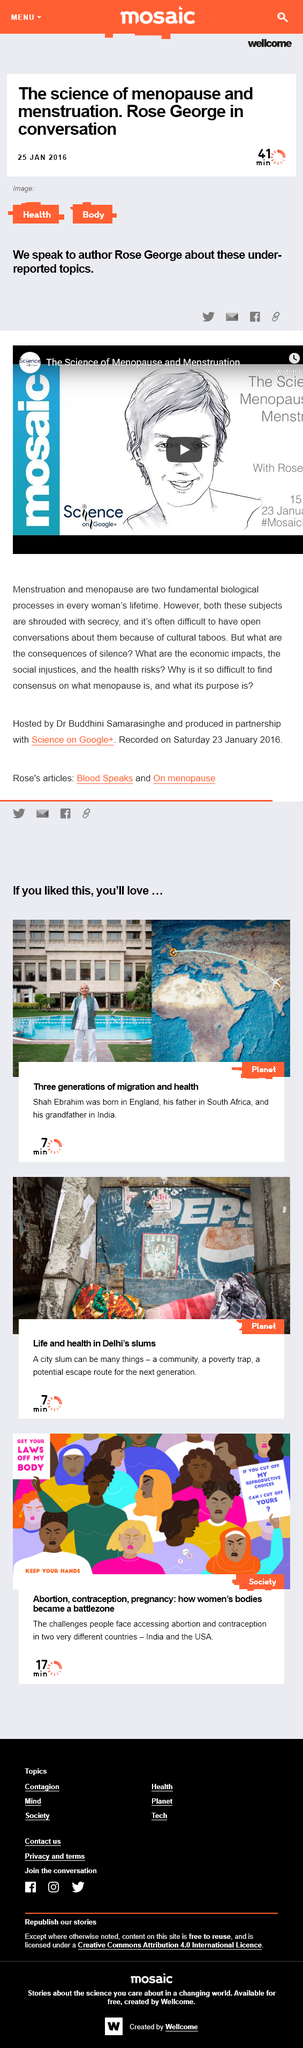Give some essential details in this illustration. The content was published on December 25, 2016. Menstruation is a fundamental biological process that occurs in every woman's lifetime. The video is about understanding the science behind menopause and menstruation. 